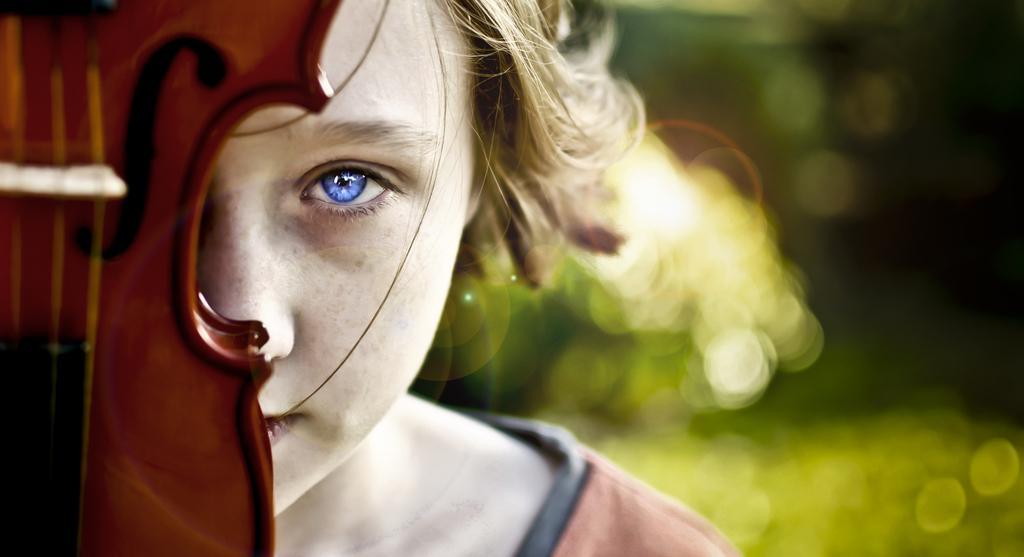How would you summarize this image in a sentence or two? In this picture there is a person. This is musical instrument. 